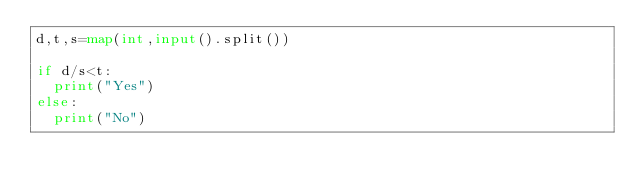<code> <loc_0><loc_0><loc_500><loc_500><_Python_>d,t,s=map(int,input().split())

if d/s<t:
  print("Yes")
else:
  print("No")</code> 